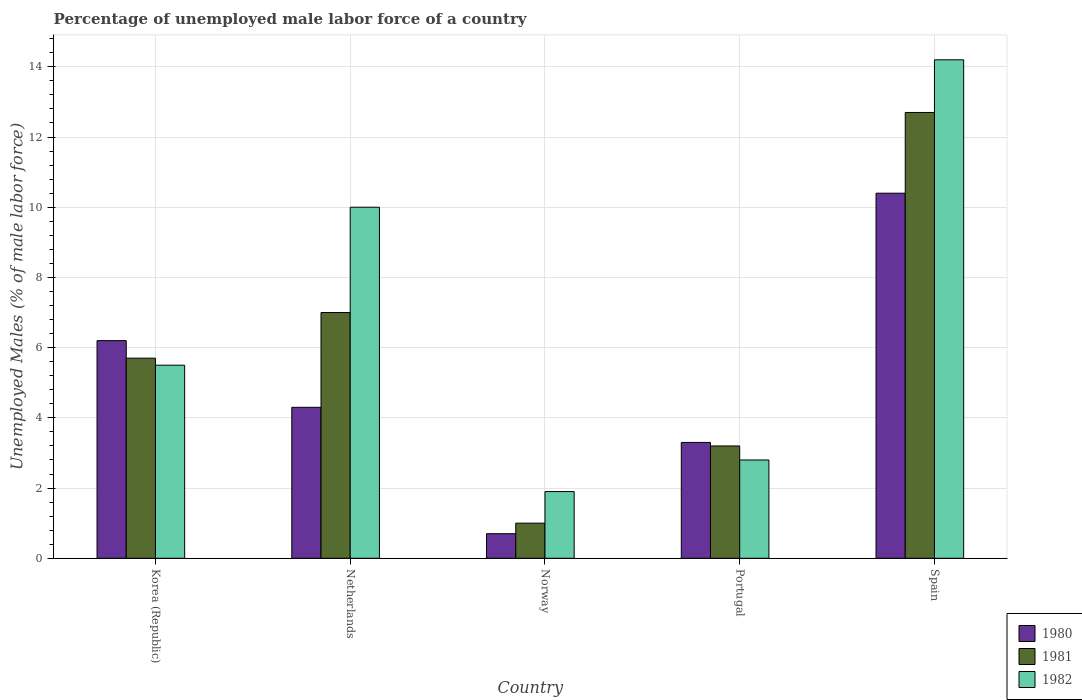How many groups of bars are there?
Provide a succinct answer. 5. How many bars are there on the 4th tick from the left?
Offer a terse response. 3. In how many cases, is the number of bars for a given country not equal to the number of legend labels?
Your answer should be very brief. 0. What is the percentage of unemployed male labor force in 1980 in Norway?
Ensure brevity in your answer.  0.7. Across all countries, what is the maximum percentage of unemployed male labor force in 1980?
Make the answer very short. 10.4. Across all countries, what is the minimum percentage of unemployed male labor force in 1980?
Your answer should be very brief. 0.7. In which country was the percentage of unemployed male labor force in 1982 maximum?
Your response must be concise. Spain. In which country was the percentage of unemployed male labor force in 1982 minimum?
Provide a short and direct response. Norway. What is the total percentage of unemployed male labor force in 1980 in the graph?
Give a very brief answer. 24.9. What is the difference between the percentage of unemployed male labor force in 1981 in Portugal and that in Spain?
Make the answer very short. -9.5. What is the difference between the percentage of unemployed male labor force in 1980 in Netherlands and the percentage of unemployed male labor force in 1981 in Norway?
Provide a succinct answer. 3.3. What is the average percentage of unemployed male labor force in 1980 per country?
Provide a short and direct response. 4.98. In how many countries, is the percentage of unemployed male labor force in 1980 greater than 4.4 %?
Your response must be concise. 2. What is the ratio of the percentage of unemployed male labor force in 1982 in Norway to that in Portugal?
Your answer should be very brief. 0.68. Is the percentage of unemployed male labor force in 1980 in Norway less than that in Portugal?
Ensure brevity in your answer.  Yes. Is the difference between the percentage of unemployed male labor force in 1982 in Korea (Republic) and Spain greater than the difference between the percentage of unemployed male labor force in 1980 in Korea (Republic) and Spain?
Your answer should be compact. No. What is the difference between the highest and the second highest percentage of unemployed male labor force in 1981?
Your answer should be very brief. 7. What is the difference between the highest and the lowest percentage of unemployed male labor force in 1980?
Offer a very short reply. 9.7. Is the sum of the percentage of unemployed male labor force in 1980 in Korea (Republic) and Spain greater than the maximum percentage of unemployed male labor force in 1982 across all countries?
Give a very brief answer. Yes. How many bars are there?
Keep it short and to the point. 15. How many countries are there in the graph?
Your answer should be very brief. 5. Are the values on the major ticks of Y-axis written in scientific E-notation?
Ensure brevity in your answer.  No. Does the graph contain any zero values?
Give a very brief answer. No. Does the graph contain grids?
Provide a succinct answer. Yes. Where does the legend appear in the graph?
Your response must be concise. Bottom right. How are the legend labels stacked?
Offer a very short reply. Vertical. What is the title of the graph?
Give a very brief answer. Percentage of unemployed male labor force of a country. Does "2007" appear as one of the legend labels in the graph?
Provide a short and direct response. No. What is the label or title of the X-axis?
Offer a terse response. Country. What is the label or title of the Y-axis?
Keep it short and to the point. Unemployed Males (% of male labor force). What is the Unemployed Males (% of male labor force) of 1980 in Korea (Republic)?
Your response must be concise. 6.2. What is the Unemployed Males (% of male labor force) in 1981 in Korea (Republic)?
Your response must be concise. 5.7. What is the Unemployed Males (% of male labor force) in 1980 in Netherlands?
Your response must be concise. 4.3. What is the Unemployed Males (% of male labor force) in 1981 in Netherlands?
Your response must be concise. 7. What is the Unemployed Males (% of male labor force) of 1980 in Norway?
Ensure brevity in your answer.  0.7. What is the Unemployed Males (% of male labor force) of 1981 in Norway?
Offer a terse response. 1. What is the Unemployed Males (% of male labor force) in 1982 in Norway?
Give a very brief answer. 1.9. What is the Unemployed Males (% of male labor force) in 1980 in Portugal?
Offer a terse response. 3.3. What is the Unemployed Males (% of male labor force) in 1981 in Portugal?
Give a very brief answer. 3.2. What is the Unemployed Males (% of male labor force) of 1982 in Portugal?
Your answer should be very brief. 2.8. What is the Unemployed Males (% of male labor force) of 1980 in Spain?
Keep it short and to the point. 10.4. What is the Unemployed Males (% of male labor force) of 1981 in Spain?
Provide a succinct answer. 12.7. What is the Unemployed Males (% of male labor force) of 1982 in Spain?
Give a very brief answer. 14.2. Across all countries, what is the maximum Unemployed Males (% of male labor force) of 1980?
Provide a short and direct response. 10.4. Across all countries, what is the maximum Unemployed Males (% of male labor force) of 1981?
Keep it short and to the point. 12.7. Across all countries, what is the maximum Unemployed Males (% of male labor force) in 1982?
Provide a short and direct response. 14.2. Across all countries, what is the minimum Unemployed Males (% of male labor force) of 1980?
Your answer should be compact. 0.7. Across all countries, what is the minimum Unemployed Males (% of male labor force) in 1982?
Your answer should be compact. 1.9. What is the total Unemployed Males (% of male labor force) of 1980 in the graph?
Your answer should be compact. 24.9. What is the total Unemployed Males (% of male labor force) of 1981 in the graph?
Your answer should be very brief. 29.6. What is the total Unemployed Males (% of male labor force) of 1982 in the graph?
Your answer should be compact. 34.4. What is the difference between the Unemployed Males (% of male labor force) of 1980 in Korea (Republic) and that in Netherlands?
Offer a terse response. 1.9. What is the difference between the Unemployed Males (% of male labor force) in 1981 in Korea (Republic) and that in Netherlands?
Make the answer very short. -1.3. What is the difference between the Unemployed Males (% of male labor force) in 1981 in Korea (Republic) and that in Norway?
Give a very brief answer. 4.7. What is the difference between the Unemployed Males (% of male labor force) of 1982 in Korea (Republic) and that in Norway?
Provide a succinct answer. 3.6. What is the difference between the Unemployed Males (% of male labor force) of 1981 in Korea (Republic) and that in Portugal?
Provide a short and direct response. 2.5. What is the difference between the Unemployed Males (% of male labor force) in 1980 in Korea (Republic) and that in Spain?
Your answer should be very brief. -4.2. What is the difference between the Unemployed Males (% of male labor force) in 1981 in Korea (Republic) and that in Spain?
Give a very brief answer. -7. What is the difference between the Unemployed Males (% of male labor force) in 1980 in Netherlands and that in Norway?
Provide a succinct answer. 3.6. What is the difference between the Unemployed Males (% of male labor force) in 1981 in Netherlands and that in Norway?
Your response must be concise. 6. What is the difference between the Unemployed Males (% of male labor force) of 1980 in Netherlands and that in Portugal?
Provide a succinct answer. 1. What is the difference between the Unemployed Males (% of male labor force) in 1981 in Netherlands and that in Portugal?
Provide a succinct answer. 3.8. What is the difference between the Unemployed Males (% of male labor force) in 1980 in Netherlands and that in Spain?
Your response must be concise. -6.1. What is the difference between the Unemployed Males (% of male labor force) in 1982 in Netherlands and that in Spain?
Provide a succinct answer. -4.2. What is the difference between the Unemployed Males (% of male labor force) of 1982 in Norway and that in Portugal?
Your answer should be compact. -0.9. What is the difference between the Unemployed Males (% of male labor force) in 1981 in Norway and that in Spain?
Offer a terse response. -11.7. What is the difference between the Unemployed Males (% of male labor force) in 1980 in Portugal and that in Spain?
Ensure brevity in your answer.  -7.1. What is the difference between the Unemployed Males (% of male labor force) in 1981 in Portugal and that in Spain?
Your answer should be very brief. -9.5. What is the difference between the Unemployed Males (% of male labor force) of 1980 in Korea (Republic) and the Unemployed Males (% of male labor force) of 1981 in Netherlands?
Offer a very short reply. -0.8. What is the difference between the Unemployed Males (% of male labor force) of 1980 in Korea (Republic) and the Unemployed Males (% of male labor force) of 1982 in Netherlands?
Keep it short and to the point. -3.8. What is the difference between the Unemployed Males (% of male labor force) of 1980 in Korea (Republic) and the Unemployed Males (% of male labor force) of 1981 in Norway?
Your answer should be compact. 5.2. What is the difference between the Unemployed Males (% of male labor force) of 1980 in Korea (Republic) and the Unemployed Males (% of male labor force) of 1981 in Portugal?
Your answer should be compact. 3. What is the difference between the Unemployed Males (% of male labor force) in 1980 in Korea (Republic) and the Unemployed Males (% of male labor force) in 1982 in Portugal?
Offer a very short reply. 3.4. What is the difference between the Unemployed Males (% of male labor force) of 1981 in Korea (Republic) and the Unemployed Males (% of male labor force) of 1982 in Portugal?
Make the answer very short. 2.9. What is the difference between the Unemployed Males (% of male labor force) in 1980 in Korea (Republic) and the Unemployed Males (% of male labor force) in 1981 in Spain?
Offer a terse response. -6.5. What is the difference between the Unemployed Males (% of male labor force) of 1980 in Korea (Republic) and the Unemployed Males (% of male labor force) of 1982 in Spain?
Provide a short and direct response. -8. What is the difference between the Unemployed Males (% of male labor force) of 1980 in Netherlands and the Unemployed Males (% of male labor force) of 1982 in Norway?
Your answer should be very brief. 2.4. What is the difference between the Unemployed Males (% of male labor force) in 1981 in Netherlands and the Unemployed Males (% of male labor force) in 1982 in Norway?
Your response must be concise. 5.1. What is the difference between the Unemployed Males (% of male labor force) in 1980 in Netherlands and the Unemployed Males (% of male labor force) in 1982 in Portugal?
Ensure brevity in your answer.  1.5. What is the difference between the Unemployed Males (% of male labor force) in 1980 in Netherlands and the Unemployed Males (% of male labor force) in 1982 in Spain?
Provide a succinct answer. -9.9. What is the difference between the Unemployed Males (% of male labor force) of 1980 in Norway and the Unemployed Males (% of male labor force) of 1981 in Portugal?
Offer a terse response. -2.5. What is the difference between the Unemployed Males (% of male labor force) of 1980 in Norway and the Unemployed Males (% of male labor force) of 1982 in Portugal?
Make the answer very short. -2.1. What is the difference between the Unemployed Males (% of male labor force) in 1980 in Portugal and the Unemployed Males (% of male labor force) in 1982 in Spain?
Keep it short and to the point. -10.9. What is the average Unemployed Males (% of male labor force) of 1980 per country?
Offer a terse response. 4.98. What is the average Unemployed Males (% of male labor force) of 1981 per country?
Provide a short and direct response. 5.92. What is the average Unemployed Males (% of male labor force) in 1982 per country?
Keep it short and to the point. 6.88. What is the difference between the Unemployed Males (% of male labor force) in 1980 and Unemployed Males (% of male labor force) in 1981 in Korea (Republic)?
Give a very brief answer. 0.5. What is the difference between the Unemployed Males (% of male labor force) in 1981 and Unemployed Males (% of male labor force) in 1982 in Korea (Republic)?
Provide a short and direct response. 0.2. What is the difference between the Unemployed Males (% of male labor force) in 1980 and Unemployed Males (% of male labor force) in 1981 in Norway?
Provide a succinct answer. -0.3. What is the difference between the Unemployed Males (% of male labor force) of 1980 and Unemployed Males (% of male labor force) of 1982 in Norway?
Your response must be concise. -1.2. What is the difference between the Unemployed Males (% of male labor force) in 1980 and Unemployed Males (% of male labor force) in 1981 in Portugal?
Make the answer very short. 0.1. What is the difference between the Unemployed Males (% of male labor force) of 1980 and Unemployed Males (% of male labor force) of 1982 in Portugal?
Provide a succinct answer. 0.5. What is the difference between the Unemployed Males (% of male labor force) in 1981 and Unemployed Males (% of male labor force) in 1982 in Portugal?
Provide a succinct answer. 0.4. What is the difference between the Unemployed Males (% of male labor force) of 1981 and Unemployed Males (% of male labor force) of 1982 in Spain?
Ensure brevity in your answer.  -1.5. What is the ratio of the Unemployed Males (% of male labor force) of 1980 in Korea (Republic) to that in Netherlands?
Your response must be concise. 1.44. What is the ratio of the Unemployed Males (% of male labor force) of 1981 in Korea (Republic) to that in Netherlands?
Offer a terse response. 0.81. What is the ratio of the Unemployed Males (% of male labor force) in 1982 in Korea (Republic) to that in Netherlands?
Provide a succinct answer. 0.55. What is the ratio of the Unemployed Males (% of male labor force) of 1980 in Korea (Republic) to that in Norway?
Make the answer very short. 8.86. What is the ratio of the Unemployed Males (% of male labor force) of 1982 in Korea (Republic) to that in Norway?
Offer a very short reply. 2.89. What is the ratio of the Unemployed Males (% of male labor force) of 1980 in Korea (Republic) to that in Portugal?
Give a very brief answer. 1.88. What is the ratio of the Unemployed Males (% of male labor force) in 1981 in Korea (Republic) to that in Portugal?
Provide a short and direct response. 1.78. What is the ratio of the Unemployed Males (% of male labor force) of 1982 in Korea (Republic) to that in Portugal?
Ensure brevity in your answer.  1.96. What is the ratio of the Unemployed Males (% of male labor force) in 1980 in Korea (Republic) to that in Spain?
Your answer should be compact. 0.6. What is the ratio of the Unemployed Males (% of male labor force) of 1981 in Korea (Republic) to that in Spain?
Your answer should be very brief. 0.45. What is the ratio of the Unemployed Males (% of male labor force) of 1982 in Korea (Republic) to that in Spain?
Your response must be concise. 0.39. What is the ratio of the Unemployed Males (% of male labor force) in 1980 in Netherlands to that in Norway?
Offer a terse response. 6.14. What is the ratio of the Unemployed Males (% of male labor force) of 1981 in Netherlands to that in Norway?
Ensure brevity in your answer.  7. What is the ratio of the Unemployed Males (% of male labor force) of 1982 in Netherlands to that in Norway?
Make the answer very short. 5.26. What is the ratio of the Unemployed Males (% of male labor force) of 1980 in Netherlands to that in Portugal?
Offer a terse response. 1.3. What is the ratio of the Unemployed Males (% of male labor force) of 1981 in Netherlands to that in Portugal?
Give a very brief answer. 2.19. What is the ratio of the Unemployed Males (% of male labor force) in 1982 in Netherlands to that in Portugal?
Ensure brevity in your answer.  3.57. What is the ratio of the Unemployed Males (% of male labor force) of 1980 in Netherlands to that in Spain?
Your response must be concise. 0.41. What is the ratio of the Unemployed Males (% of male labor force) in 1981 in Netherlands to that in Spain?
Offer a terse response. 0.55. What is the ratio of the Unemployed Males (% of male labor force) in 1982 in Netherlands to that in Spain?
Give a very brief answer. 0.7. What is the ratio of the Unemployed Males (% of male labor force) of 1980 in Norway to that in Portugal?
Offer a terse response. 0.21. What is the ratio of the Unemployed Males (% of male labor force) of 1981 in Norway to that in Portugal?
Provide a succinct answer. 0.31. What is the ratio of the Unemployed Males (% of male labor force) of 1982 in Norway to that in Portugal?
Give a very brief answer. 0.68. What is the ratio of the Unemployed Males (% of male labor force) of 1980 in Norway to that in Spain?
Keep it short and to the point. 0.07. What is the ratio of the Unemployed Males (% of male labor force) of 1981 in Norway to that in Spain?
Keep it short and to the point. 0.08. What is the ratio of the Unemployed Males (% of male labor force) of 1982 in Norway to that in Spain?
Your answer should be very brief. 0.13. What is the ratio of the Unemployed Males (% of male labor force) in 1980 in Portugal to that in Spain?
Your answer should be very brief. 0.32. What is the ratio of the Unemployed Males (% of male labor force) of 1981 in Portugal to that in Spain?
Offer a very short reply. 0.25. What is the ratio of the Unemployed Males (% of male labor force) of 1982 in Portugal to that in Spain?
Offer a terse response. 0.2. What is the difference between the highest and the second highest Unemployed Males (% of male labor force) of 1981?
Your response must be concise. 5.7. What is the difference between the highest and the second highest Unemployed Males (% of male labor force) in 1982?
Give a very brief answer. 4.2. What is the difference between the highest and the lowest Unemployed Males (% of male labor force) in 1981?
Offer a terse response. 11.7. 